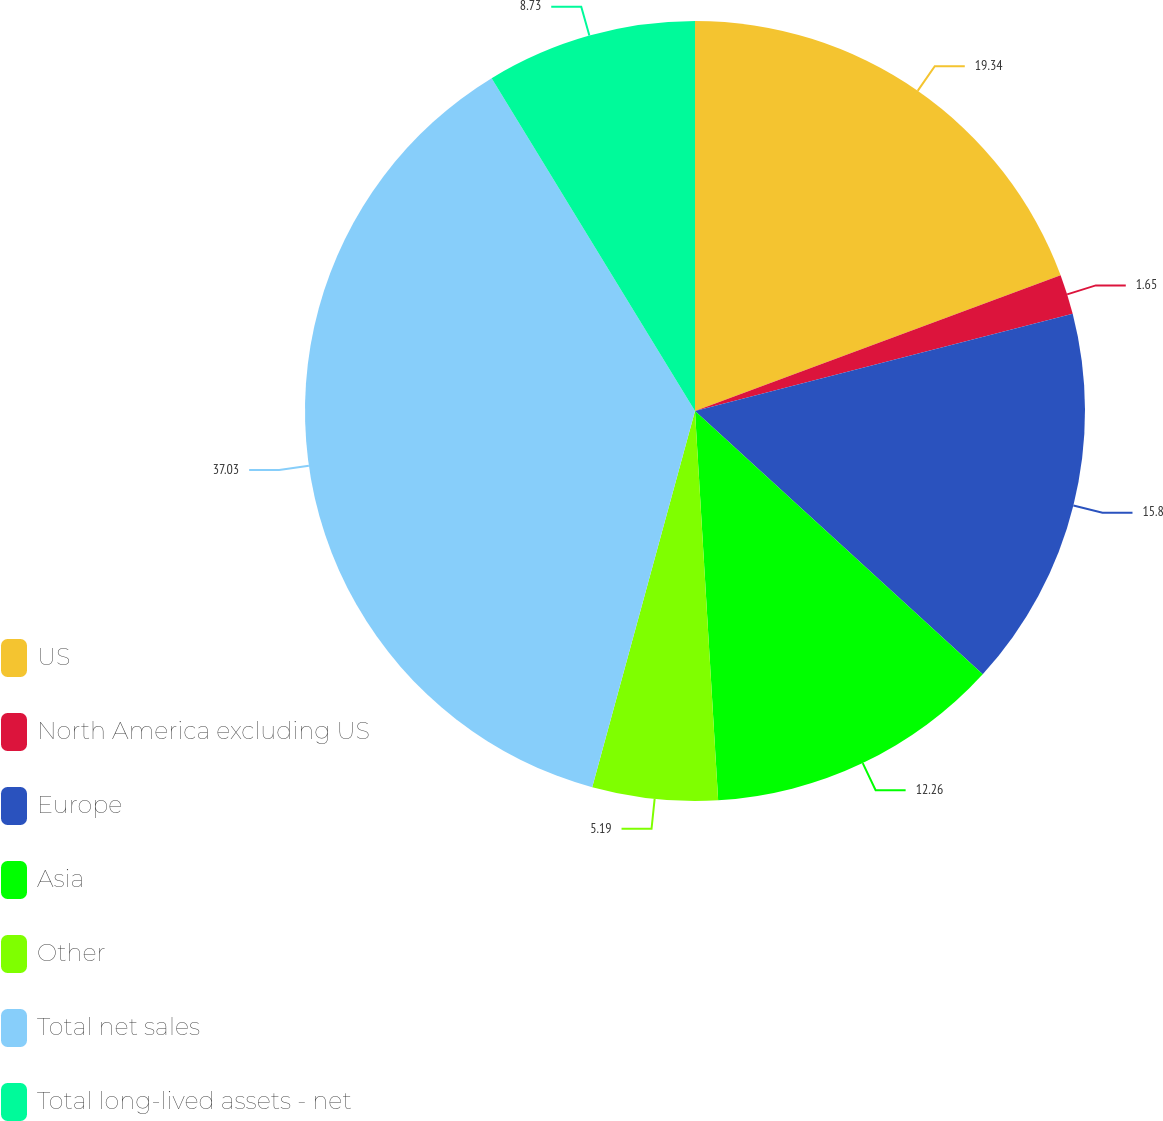Convert chart. <chart><loc_0><loc_0><loc_500><loc_500><pie_chart><fcel>US<fcel>North America excluding US<fcel>Europe<fcel>Asia<fcel>Other<fcel>Total net sales<fcel>Total long-lived assets - net<nl><fcel>19.34%<fcel>1.65%<fcel>15.8%<fcel>12.26%<fcel>5.19%<fcel>37.02%<fcel>8.73%<nl></chart> 